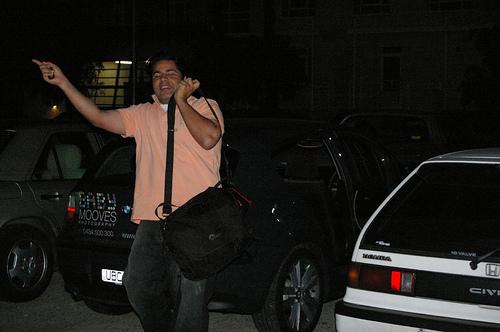What model is the white car?
Short answer required. Civic. Which hand is pointing?
Quick response, please. Right. Is the man wearing a long-sleeved shirt?
Be succinct. No. 